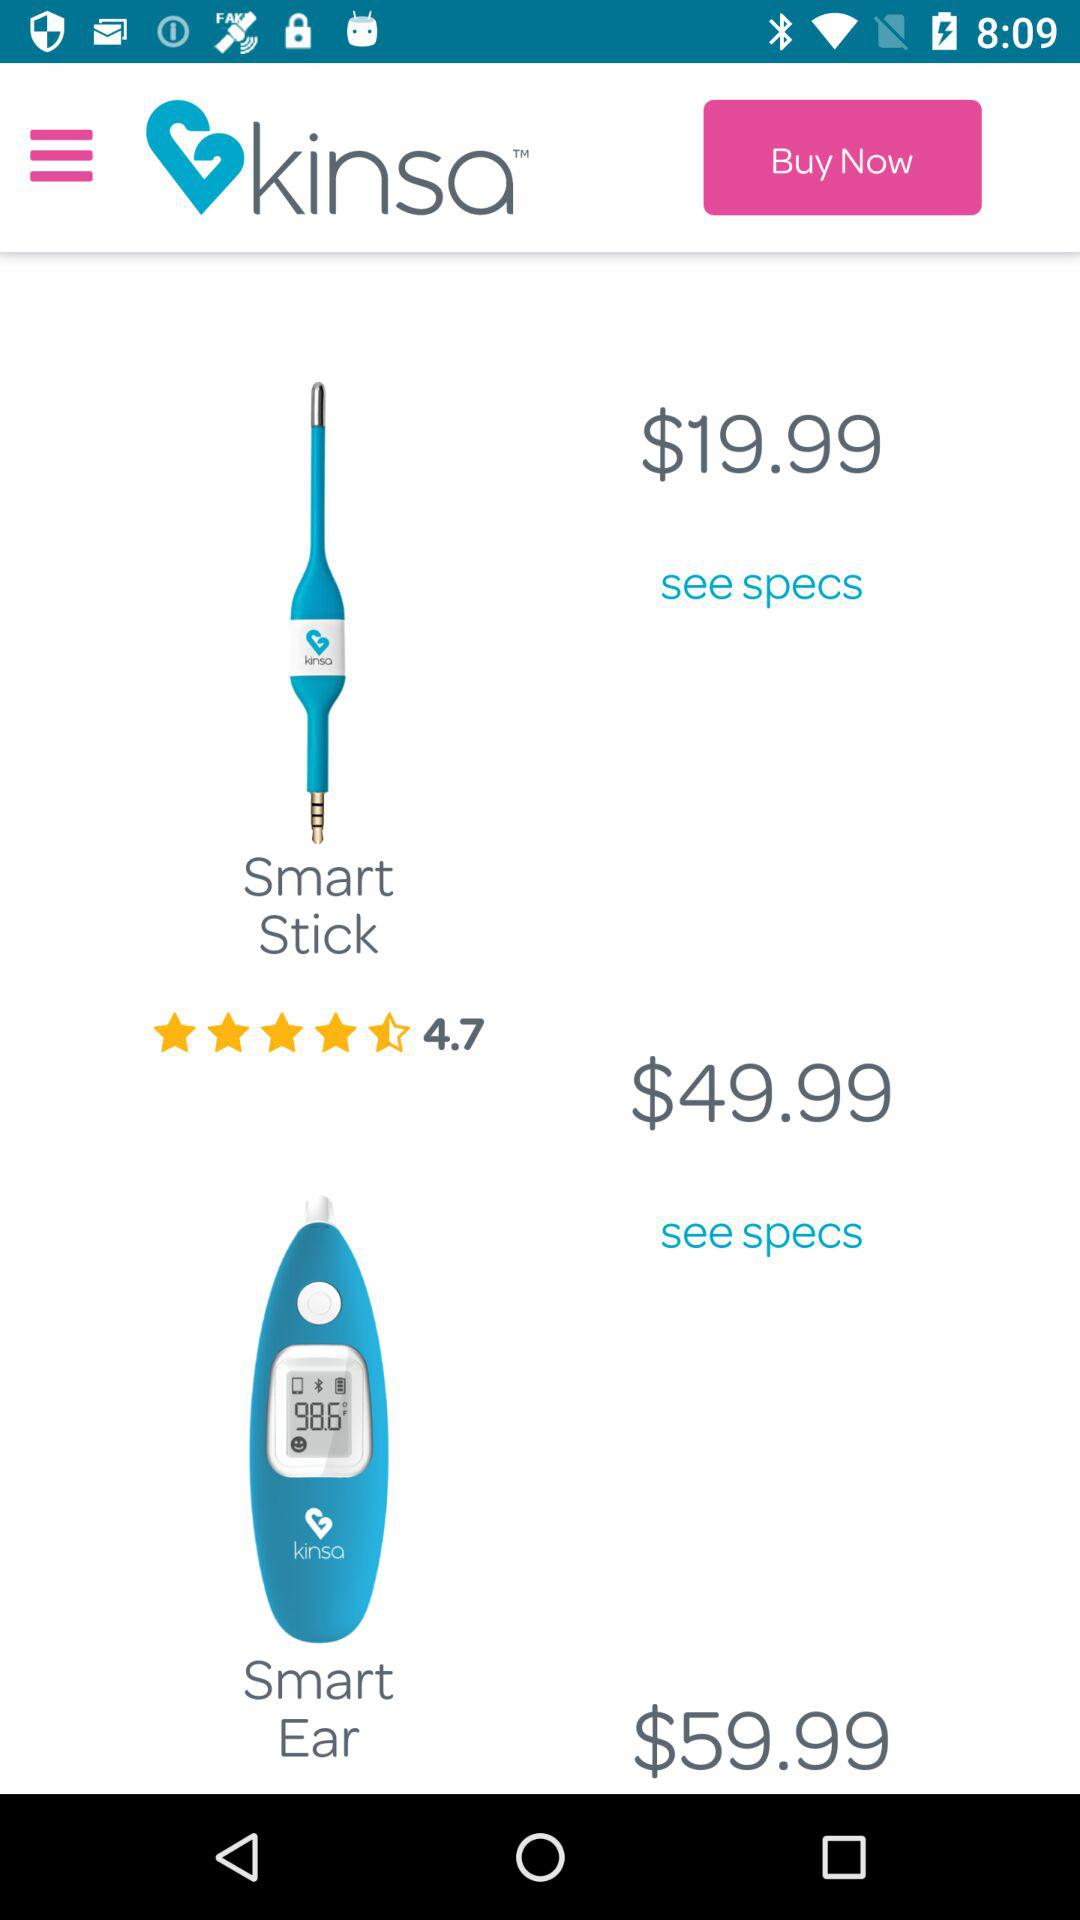What is the price of a smart stick? The price of a smart stick is $19.99. 